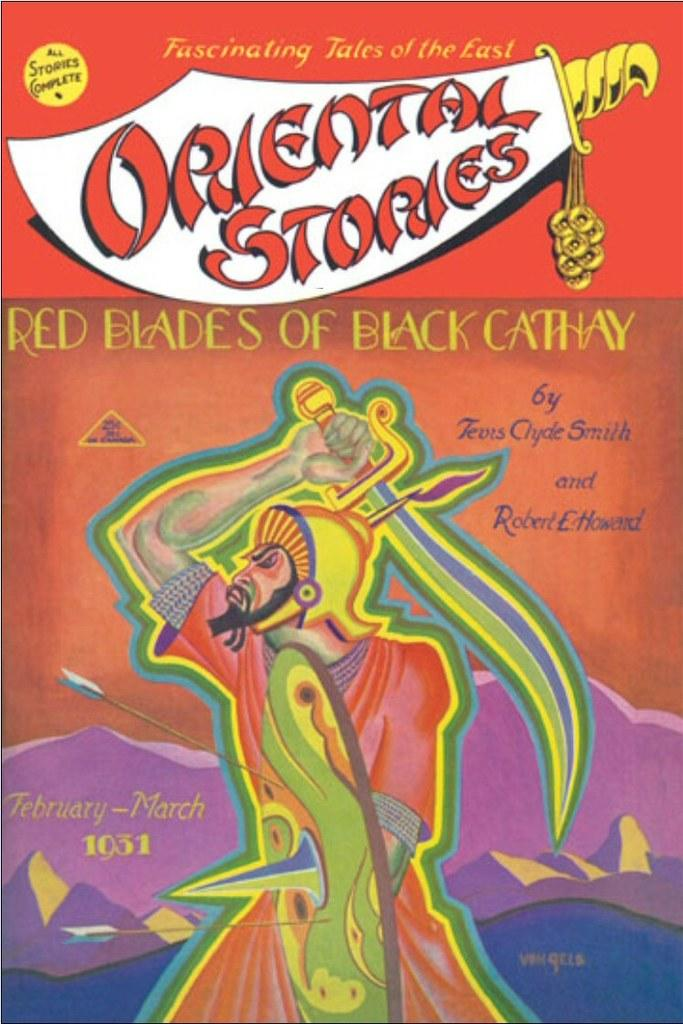What is depicted on the poster in the image? The poster features a man holding a sword. What else can be seen on the poster besides the man with a sword? There is text written on the poster. What colors are used in the poster? The poster has red, brown, pink, and white colors. Can you see any crayons being used by the fairies in the image? There are no fairies or crayons present in the image. What type of comb is the man using to style his hair in the image? There is no comb visible in the image, and the man's hair is not being styled. 